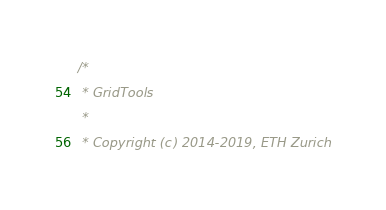Convert code to text. <code><loc_0><loc_0><loc_500><loc_500><_C++_>/*
 * GridTools
 *
 * Copyright (c) 2014-2019, ETH Zurich</code> 